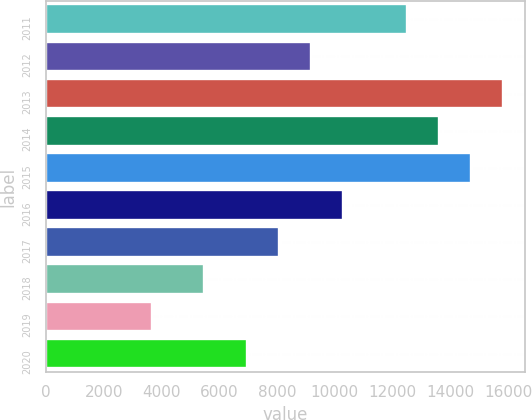<chart> <loc_0><loc_0><loc_500><loc_500><bar_chart><fcel>2011<fcel>2012<fcel>2013<fcel>2014<fcel>2015<fcel>2016<fcel>2017<fcel>2018<fcel>2019<fcel>2020<nl><fcel>12495.5<fcel>9182.6<fcel>15808.4<fcel>13599.8<fcel>14704.1<fcel>10286.9<fcel>8078.3<fcel>5461<fcel>3670<fcel>6974<nl></chart> 